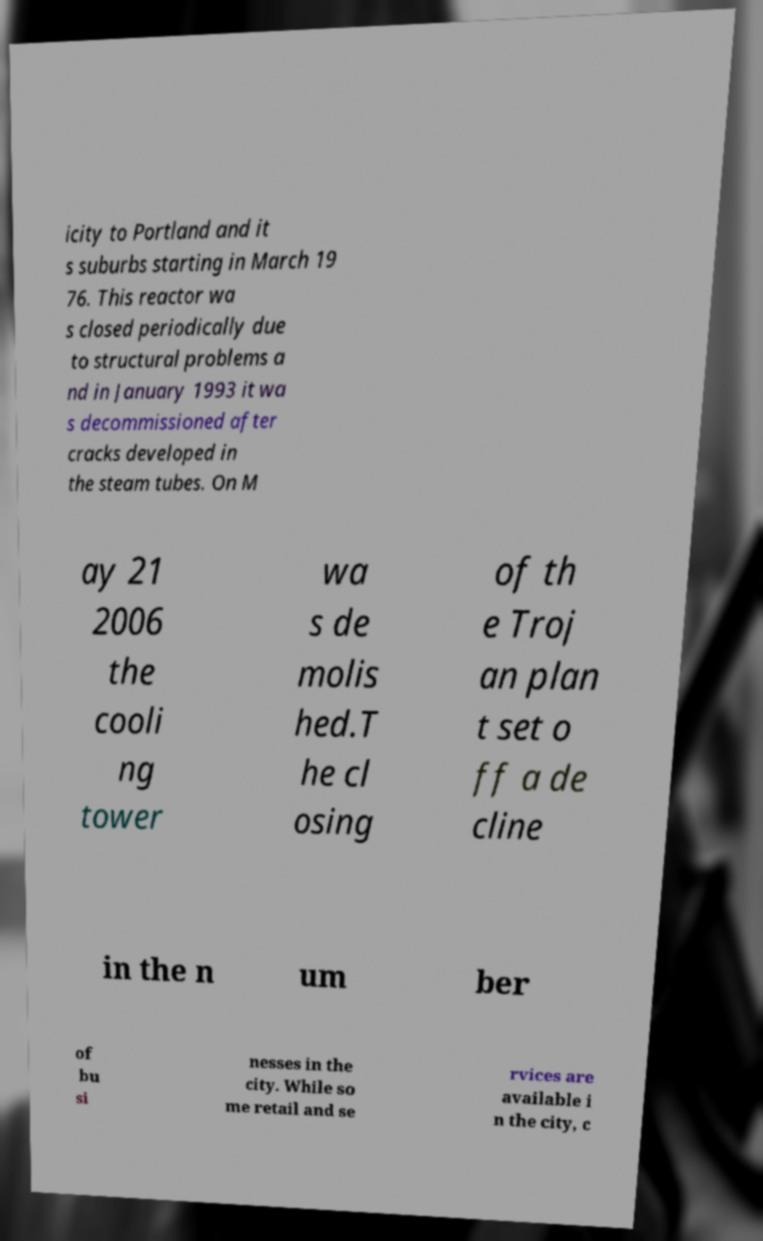I need the written content from this picture converted into text. Can you do that? icity to Portland and it s suburbs starting in March 19 76. This reactor wa s closed periodically due to structural problems a nd in January 1993 it wa s decommissioned after cracks developed in the steam tubes. On M ay 21 2006 the cooli ng tower wa s de molis hed.T he cl osing of th e Troj an plan t set o ff a de cline in the n um ber of bu si nesses in the city. While so me retail and se rvices are available i n the city, c 